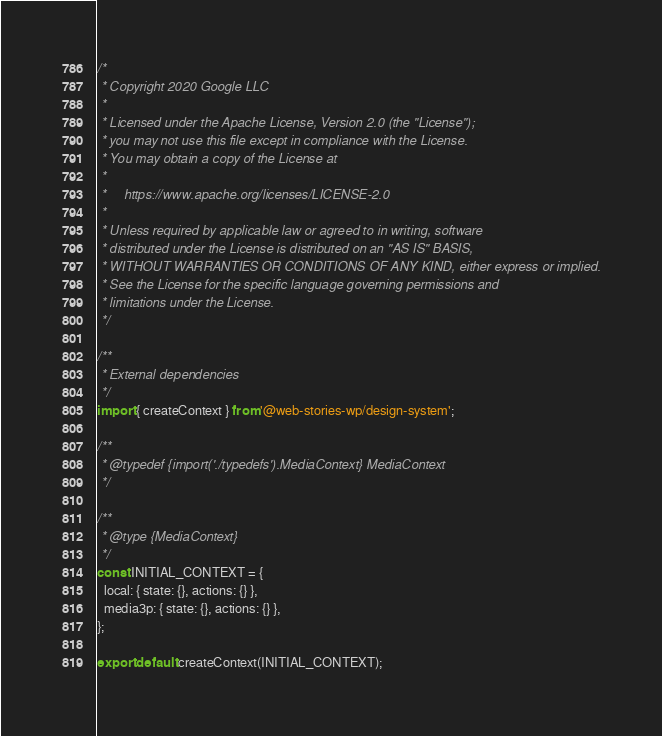<code> <loc_0><loc_0><loc_500><loc_500><_JavaScript_>/*
 * Copyright 2020 Google LLC
 *
 * Licensed under the Apache License, Version 2.0 (the "License");
 * you may not use this file except in compliance with the License.
 * You may obtain a copy of the License at
 *
 *     https://www.apache.org/licenses/LICENSE-2.0
 *
 * Unless required by applicable law or agreed to in writing, software
 * distributed under the License is distributed on an "AS IS" BASIS,
 * WITHOUT WARRANTIES OR CONDITIONS OF ANY KIND, either express or implied.
 * See the License for the specific language governing permissions and
 * limitations under the License.
 */

/**
 * External dependencies
 */
import { createContext } from '@web-stories-wp/design-system';

/**
 * @typedef {import('./typedefs').MediaContext} MediaContext
 */

/**
 * @type {MediaContext}
 */
const INITIAL_CONTEXT = {
  local: { state: {}, actions: {} },
  media3p: { state: {}, actions: {} },
};

export default createContext(INITIAL_CONTEXT);
</code> 